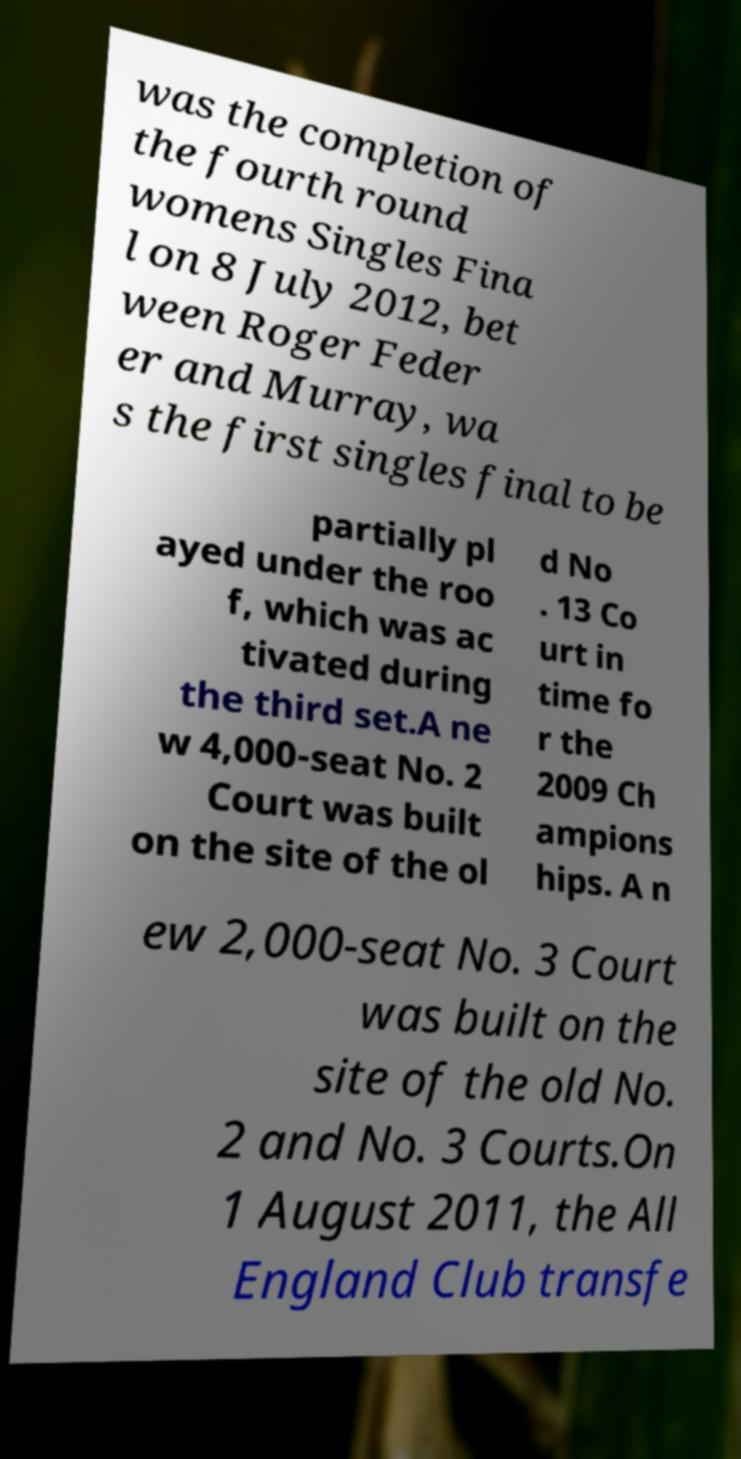Could you extract and type out the text from this image? was the completion of the fourth round womens Singles Fina l on 8 July 2012, bet ween Roger Feder er and Murray, wa s the first singles final to be partially pl ayed under the roo f, which was ac tivated during the third set.A ne w 4,000-seat No. 2 Court was built on the site of the ol d No . 13 Co urt in time fo r the 2009 Ch ampions hips. A n ew 2,000-seat No. 3 Court was built on the site of the old No. 2 and No. 3 Courts.On 1 August 2011, the All England Club transfe 